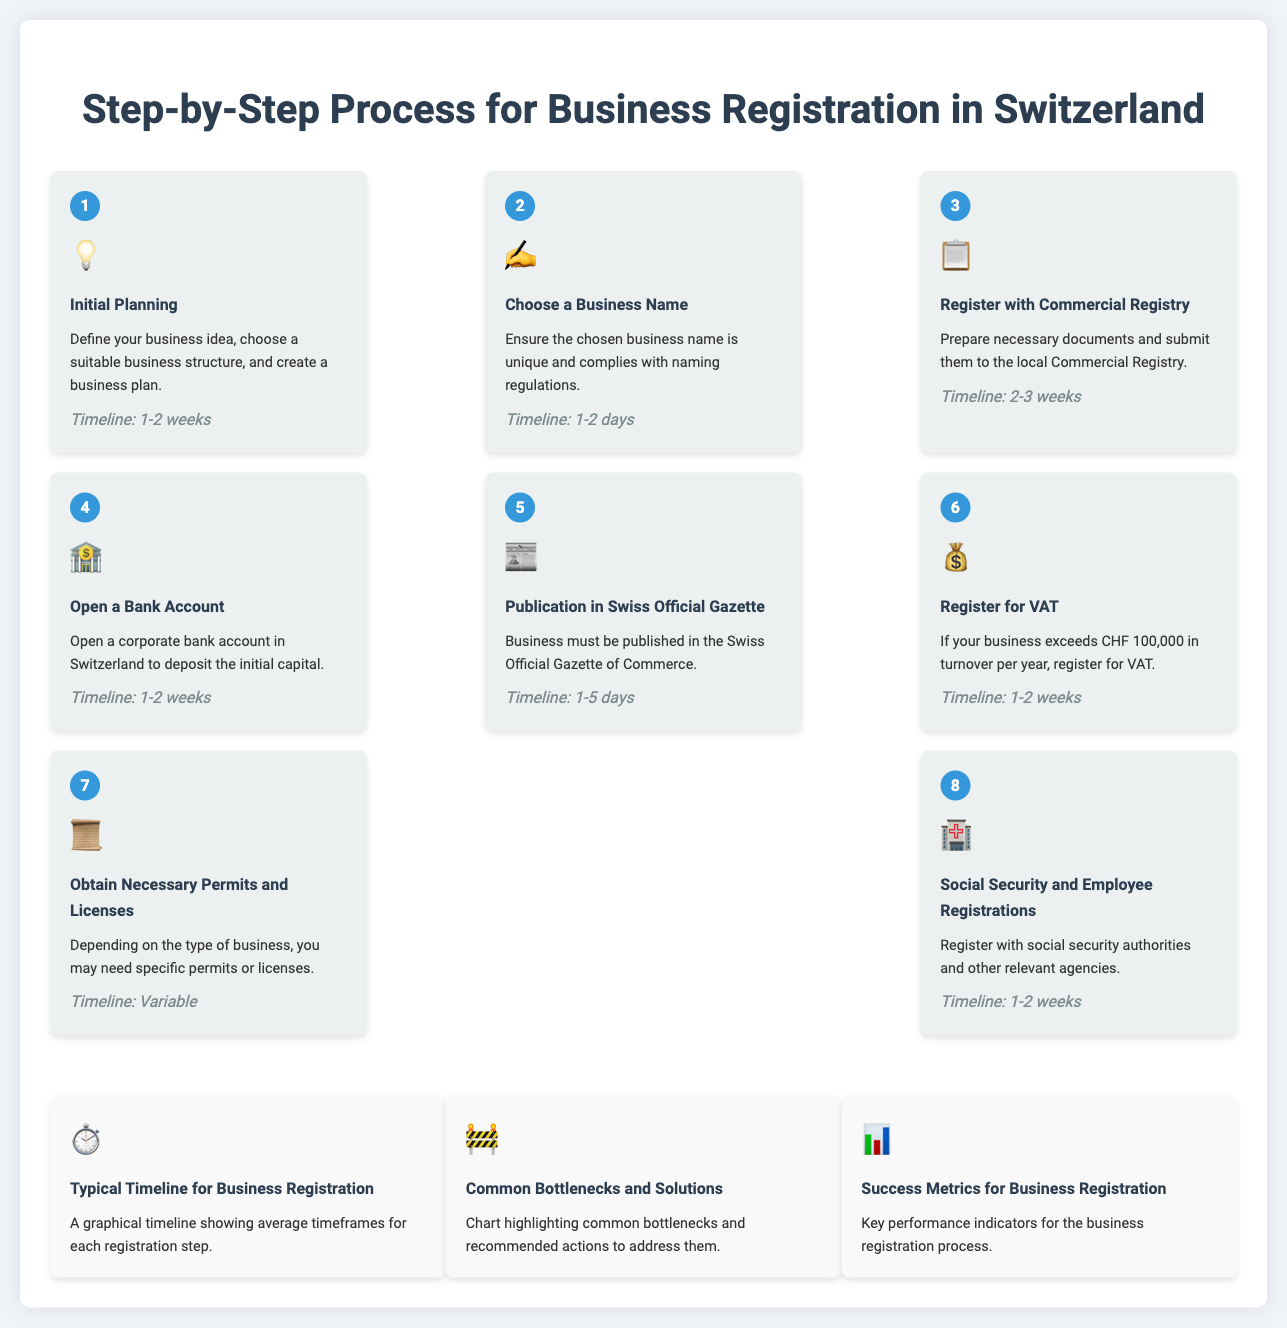what is the timeline for initial planning? The timeline for initial planning, as stated in the document, is 1-2 weeks.
Answer: 1-2 weeks which step involves opening a bank account? The step involving opening a bank account is Step 4, titled "Open a Bank Account."
Answer: Step 4 what is the main requirement for VAT registration? The main requirement for VAT registration is if your business exceeds CHF 100,000 in turnover per year.
Answer: CHF 100,000 how many steps are outlined for the business registration process? The document outlines a total of 8 steps for the business registration process.
Answer: 8 steps what chart discusses common bottlenecks? The chart discussing common bottlenecks is titled "Common Bottlenecks and Solutions."
Answer: Common Bottlenecks and Solutions what is the focus of the success metrics chart? The focus of the success metrics chart is on key performance indicators for the business registration process.
Answer: key performance indicators which step requires publication in the Swiss Official Gazette? The step that requires publication in the Swiss Official Gazette is Step 5, titled "Publication in Swiss Official Gazette."
Answer: Step 5 what is the timeline for obtaining necessary permits and licenses? The timeline for obtaining necessary permits and licenses is variable, as indicated in the document.
Answer: Variable 